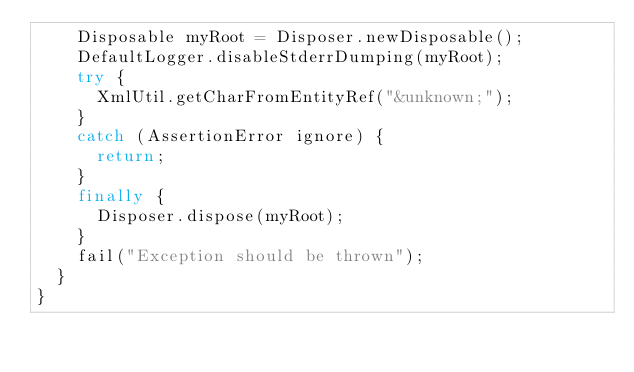Convert code to text. <code><loc_0><loc_0><loc_500><loc_500><_Java_>    Disposable myRoot = Disposer.newDisposable();
    DefaultLogger.disableStderrDumping(myRoot);
    try {
      XmlUtil.getCharFromEntityRef("&unknown;");
    }
    catch (AssertionError ignore) {
      return;
    }
    finally {
      Disposer.dispose(myRoot);
    }
    fail("Exception should be thrown");
  }
}
</code> 